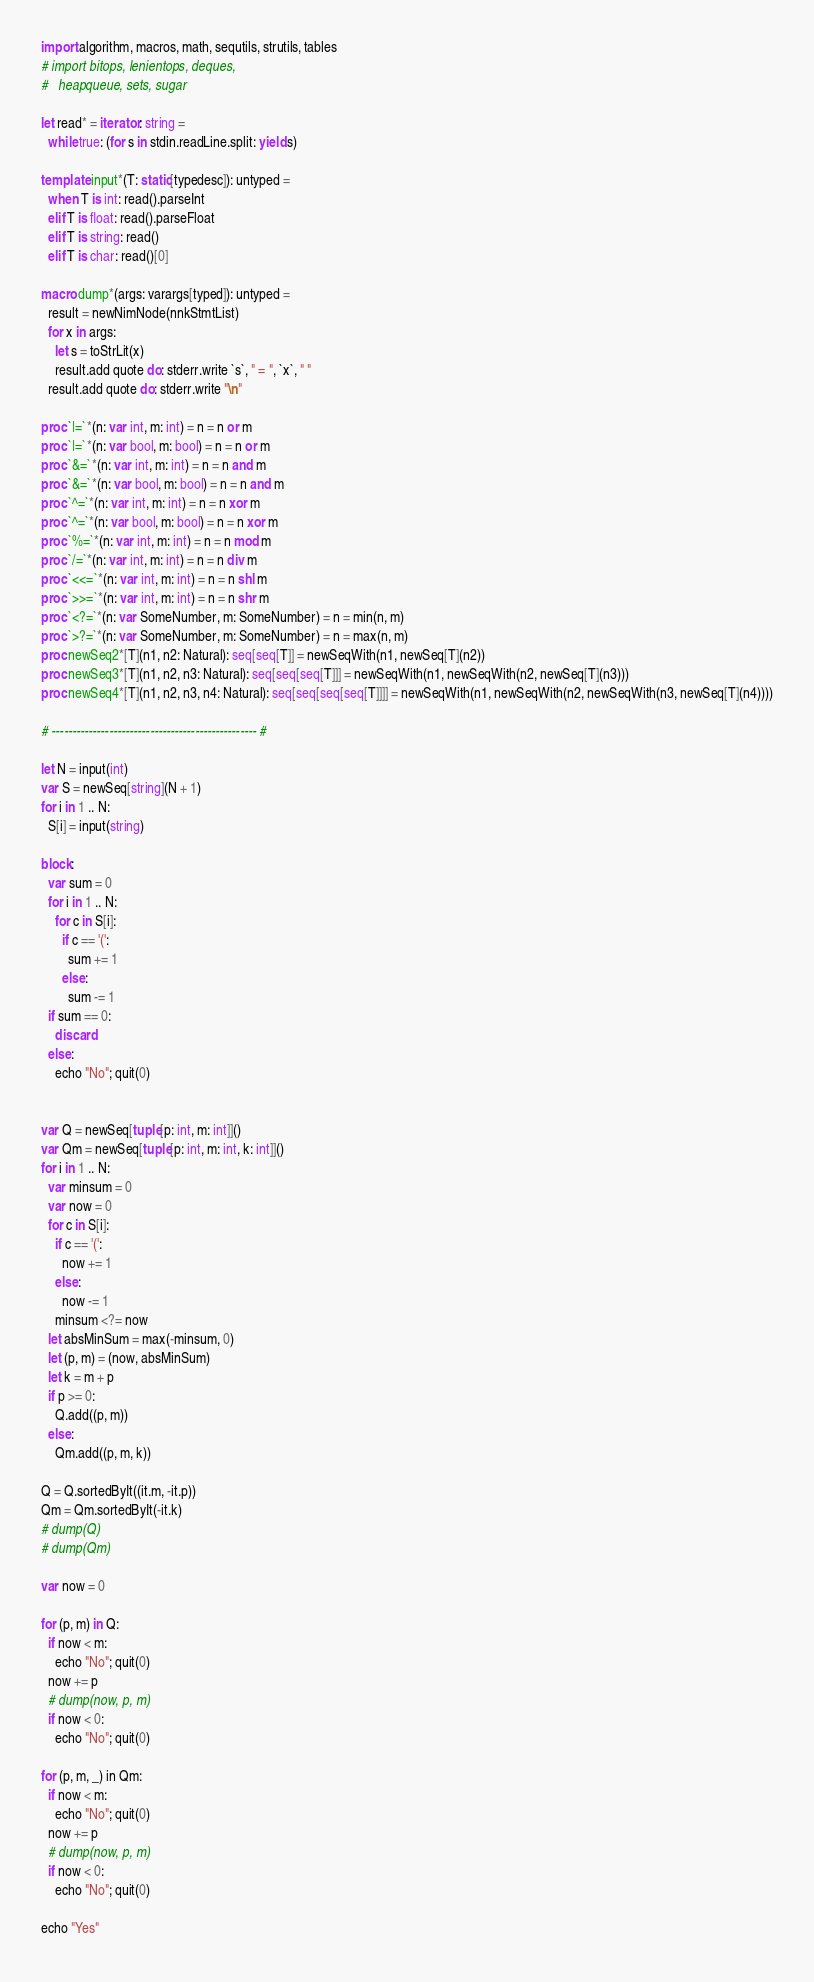<code> <loc_0><loc_0><loc_500><loc_500><_Nim_>import algorithm, macros, math, sequtils, strutils, tables
# import bitops, lenientops, deques,
#   heapqueue, sets, sugar

let read* = iterator: string =
  while true: (for s in stdin.readLine.split: yield s)

template input*(T: static[typedesc]): untyped = 
  when T is int: read().parseInt
  elif T is float: read().parseFloat
  elif T is string: read()
  elif T is char: read()[0]

macro dump*(args: varargs[typed]): untyped =
  result = newNimNode(nnkStmtList)
  for x in args:
    let s = toStrLit(x)
    result.add quote do: stderr.write `s`, " = ", `x`, " "
  result.add quote do: stderr.write "\n"

proc `|=`*(n: var int, m: int) = n = n or m
proc `|=`*(n: var bool, m: bool) = n = n or m
proc `&=`*(n: var int, m: int) = n = n and m
proc `&=`*(n: var bool, m: bool) = n = n and m
proc `^=`*(n: var int, m: int) = n = n xor m
proc `^=`*(n: var bool, m: bool) = n = n xor m
proc `%=`*(n: var int, m: int) = n = n mod m
proc `/=`*(n: var int, m: int) = n = n div m
proc `<<=`*(n: var int, m: int) = n = n shl m
proc `>>=`*(n: var int, m: int) = n = n shr m
proc `<?=`*(n: var SomeNumber, m: SomeNumber) = n = min(n, m)
proc `>?=`*(n: var SomeNumber, m: SomeNumber) = n = max(n, m)
proc newSeq2*[T](n1, n2: Natural): seq[seq[T]] = newSeqWith(n1, newSeq[T](n2))
proc newSeq3*[T](n1, n2, n3: Natural): seq[seq[seq[T]]] = newSeqWith(n1, newSeqWith(n2, newSeq[T](n3)))
proc newSeq4*[T](n1, n2, n3, n4: Natural): seq[seq[seq[seq[T]]]] = newSeqWith(n1, newSeqWith(n2, newSeqWith(n3, newSeq[T](n4))))

# -------------------------------------------------- #

let N = input(int)
var S = newSeq[string](N + 1)
for i in 1 .. N:
  S[i] = input(string)

block:
  var sum = 0
  for i in 1 .. N:
    for c in S[i]:
      if c == '(':
        sum += 1
      else:
        sum -= 1
  if sum == 0:
    discard
  else:
    echo "No"; quit(0)


var Q = newSeq[tuple[p: int, m: int]]()
var Qm = newSeq[tuple[p: int, m: int, k: int]]()
for i in 1 .. N:
  var minsum = 0
  var now = 0
  for c in S[i]:
    if c == '(':
      now += 1
    else:
      now -= 1
    minsum <?= now
  let absMinSum = max(-minsum, 0)
  let (p, m) = (now, absMinSum)
  let k = m + p
  if p >= 0:
    Q.add((p, m))
  else:
    Qm.add((p, m, k))

Q = Q.sortedByIt((it.m, -it.p))
Qm = Qm.sortedByIt(-it.k)
# dump(Q)
# dump(Qm)

var now = 0

for (p, m) in Q:
  if now < m:
    echo "No"; quit(0)
  now += p
  # dump(now, p, m)
  if now < 0:
    echo "No"; quit(0)

for (p, m, _) in Qm:
  if now < m:
    echo "No"; quit(0)
  now += p
  # dump(now, p, m)
  if now < 0:
    echo "No"; quit(0)

echo "Yes"
</code> 